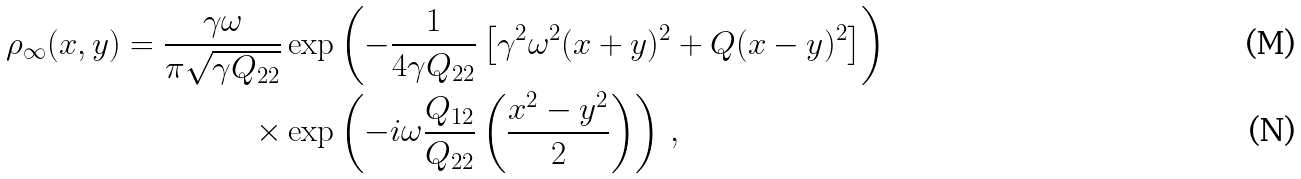<formula> <loc_0><loc_0><loc_500><loc_500>\rho _ { \infty } ( x , y ) = \frac { \gamma \omega } { \pi \sqrt { \gamma Q _ { 2 2 } } } & \exp \left ( - \frac { 1 } { 4 \gamma Q _ { 2 2 } } \left [ \gamma ^ { 2 } \omega ^ { 2 } ( x + y ) ^ { 2 } + Q ( x - y ) ^ { 2 } \right ] \right ) \\ \times & \exp \left ( - i \omega \frac { Q _ { 1 2 } } { Q _ { 2 2 } } \left ( \frac { x ^ { 2 } - y ^ { 2 } } { 2 } \right ) \right ) \, ,</formula> 